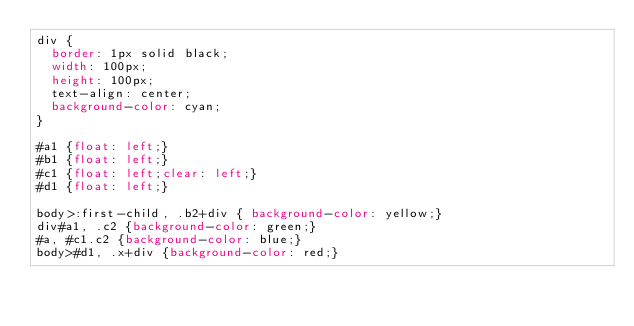<code> <loc_0><loc_0><loc_500><loc_500><_CSS_>div {
  border: 1px solid black;
  width: 100px;
  height: 100px;
  text-align: center;
  background-color: cyan;
}

#a1 {float: left;}
#b1 {float: left;}
#c1 {float: left;clear: left;}
#d1 {float: left;}

body>:first-child, .b2+div { background-color: yellow;}
div#a1, .c2 {background-color: green;}
#a, #c1.c2 {background-color: blue;}
body>#d1, .x+div {background-color: red;}</code> 